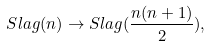Convert formula to latex. <formula><loc_0><loc_0><loc_500><loc_500>S l a g ( n ) \to S l a g ( \frac { n ( n + 1 ) } { 2 } ) ,</formula> 